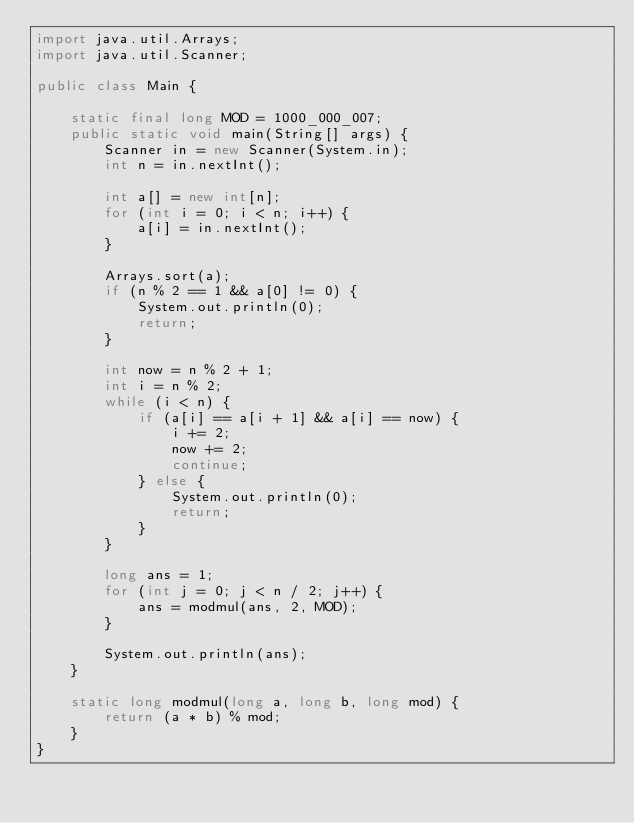<code> <loc_0><loc_0><loc_500><loc_500><_Java_>import java.util.Arrays;
import java.util.Scanner;

public class Main {

    static final long MOD = 1000_000_007;
    public static void main(String[] args) {
        Scanner in = new Scanner(System.in);
        int n = in.nextInt();

        int a[] = new int[n];
        for (int i = 0; i < n; i++) {
            a[i] = in.nextInt();
        }

        Arrays.sort(a);
        if (n % 2 == 1 && a[0] != 0) {
            System.out.println(0);
            return;
        }

        int now = n % 2 + 1;
        int i = n % 2;
        while (i < n) {
            if (a[i] == a[i + 1] && a[i] == now) {
                i += 2;
                now += 2;
                continue;
            } else {
                System.out.println(0);
                return;
            }
        }

        long ans = 1;
        for (int j = 0; j < n / 2; j++) {
            ans = modmul(ans, 2, MOD);
        }

        System.out.println(ans);
    }

    static long modmul(long a, long b, long mod) {
        return (a * b) % mod;
    }
}</code> 